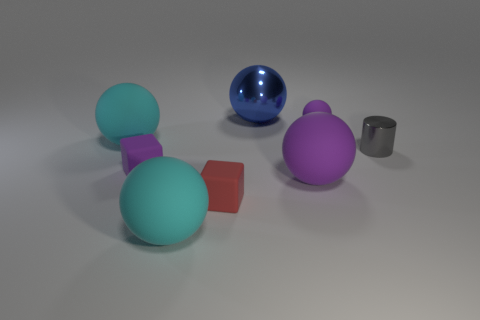Subtract all large purple balls. How many balls are left? 4 Add 1 blue metallic balls. How many objects exist? 9 Subtract 4 spheres. How many spheres are left? 1 Subtract all purple balls. How many balls are left? 3 Subtract all purple balls. How many purple cylinders are left? 0 Subtract all metallic things. Subtract all small rubber objects. How many objects are left? 3 Add 8 tiny purple matte objects. How many tiny purple matte objects are left? 10 Add 1 green matte cylinders. How many green matte cylinders exist? 1 Subtract 1 gray cylinders. How many objects are left? 7 Subtract all cubes. How many objects are left? 6 